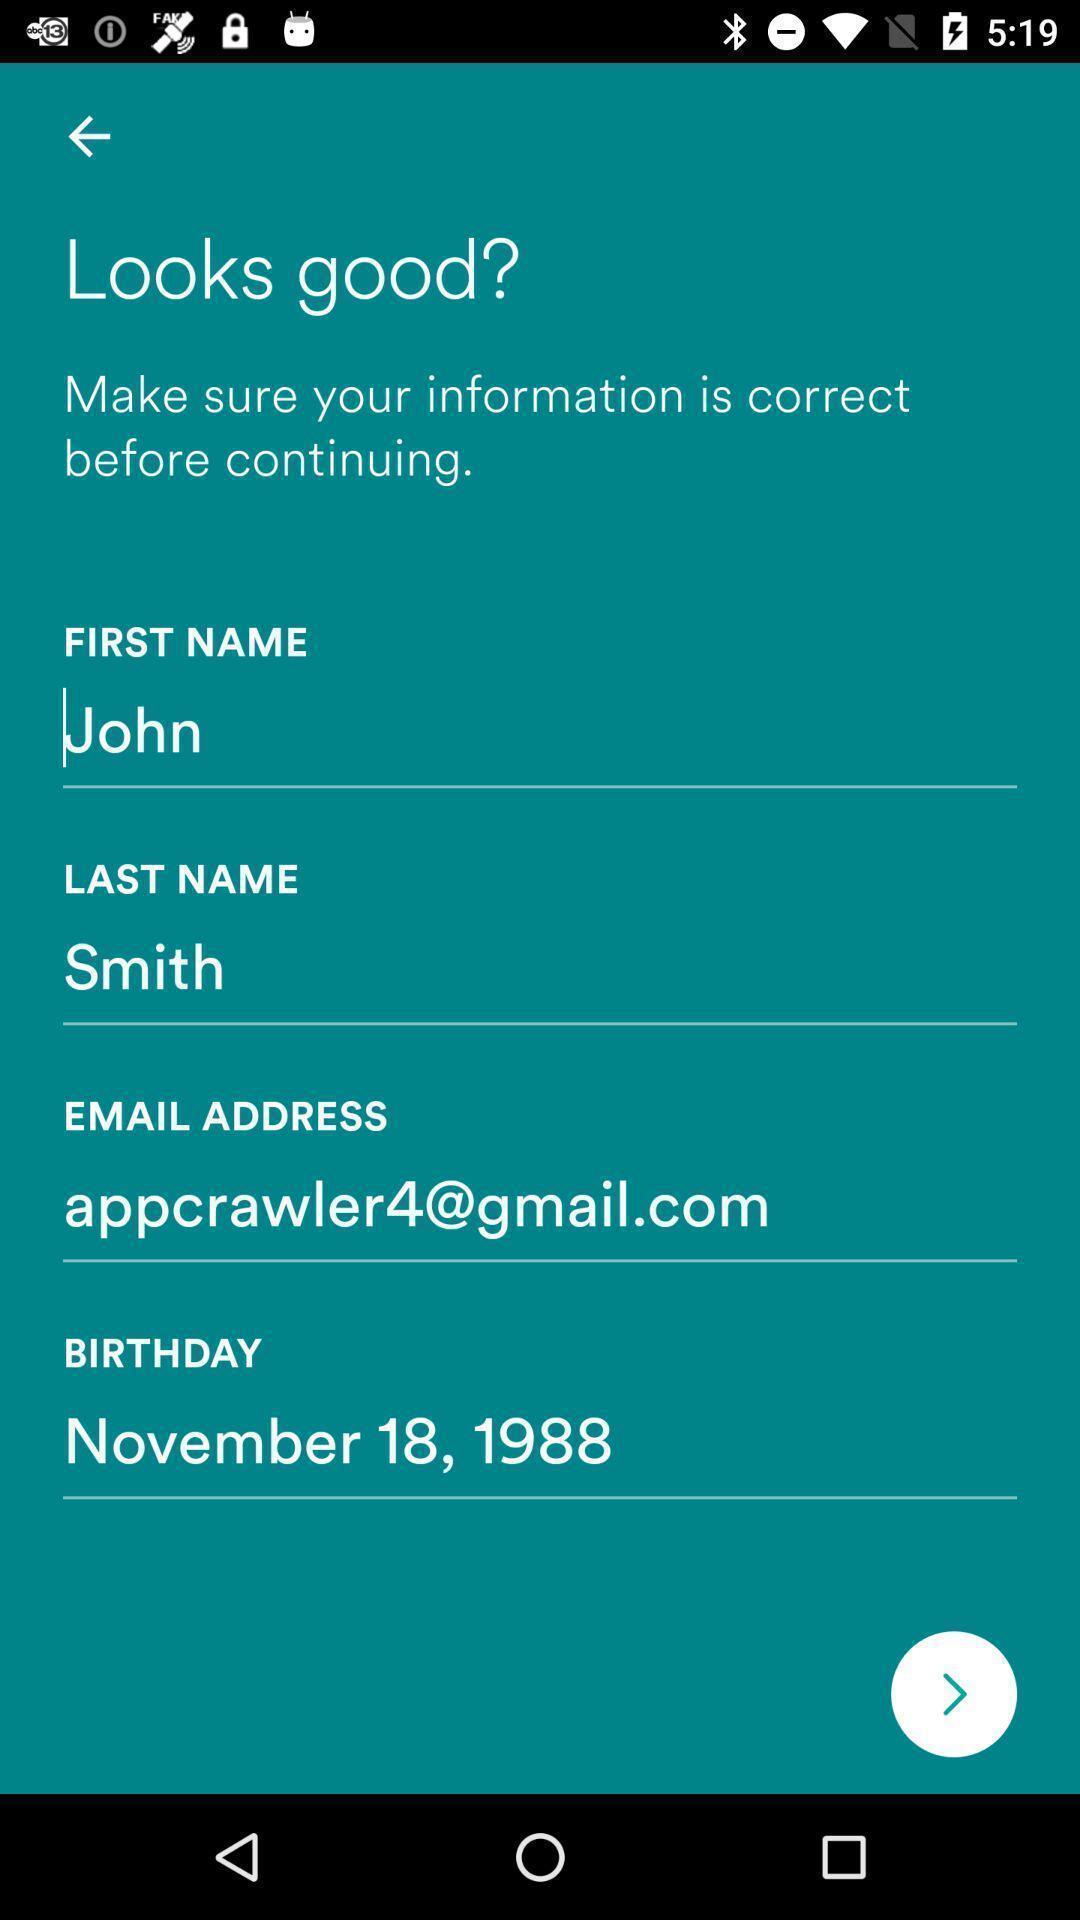Explain what's happening in this screen capture. Page displaying the information of the user. 